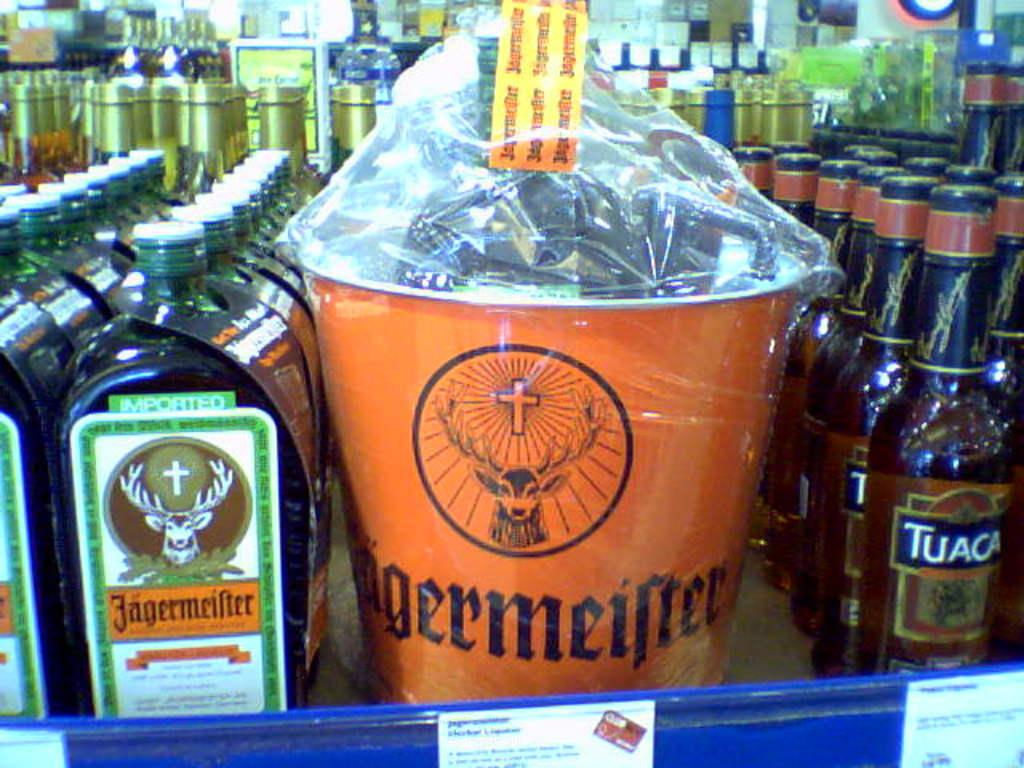<image>
Summarize the visual content of the image. A few rows of Jagermeifer with a bucket in the middle of the rows containing Jagermeifer. 